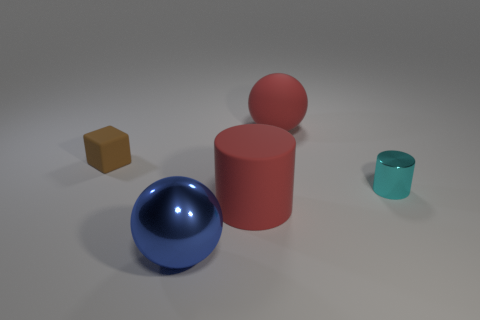Subtract 2 balls. How many balls are left? 0 Subtract all red cylinders. How many cylinders are left? 1 Subtract all cubes. How many objects are left? 4 Add 3 big rubber blocks. How many objects exist? 8 Subtract all small brown matte things. Subtract all purple metal cylinders. How many objects are left? 4 Add 4 big blue shiny things. How many big blue shiny things are left? 5 Add 2 big blue spheres. How many big blue spheres exist? 3 Subtract 0 blue cylinders. How many objects are left? 5 Subtract all brown balls. Subtract all purple cylinders. How many balls are left? 2 Subtract all cyan cylinders. How many blue balls are left? 1 